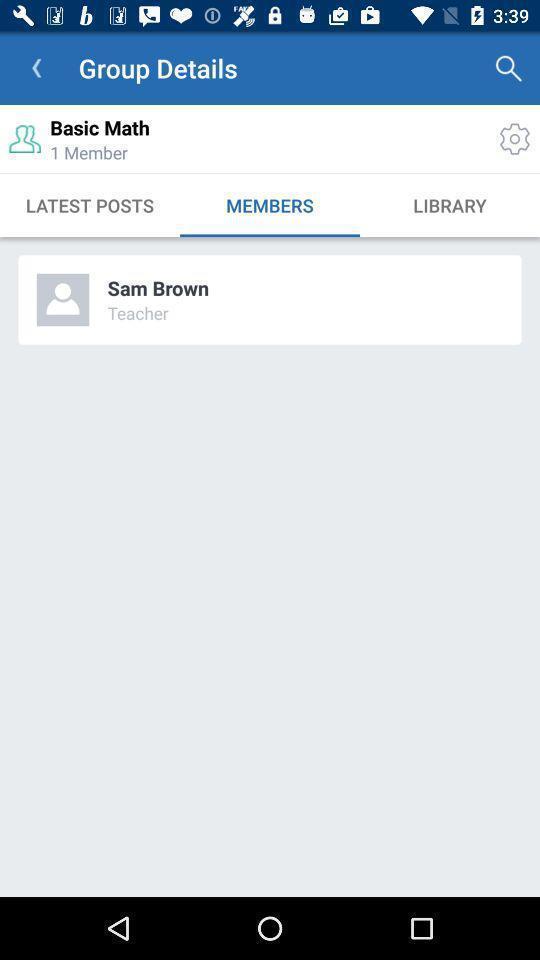Provide a description of this screenshot. Page showing search results with multiple options. 